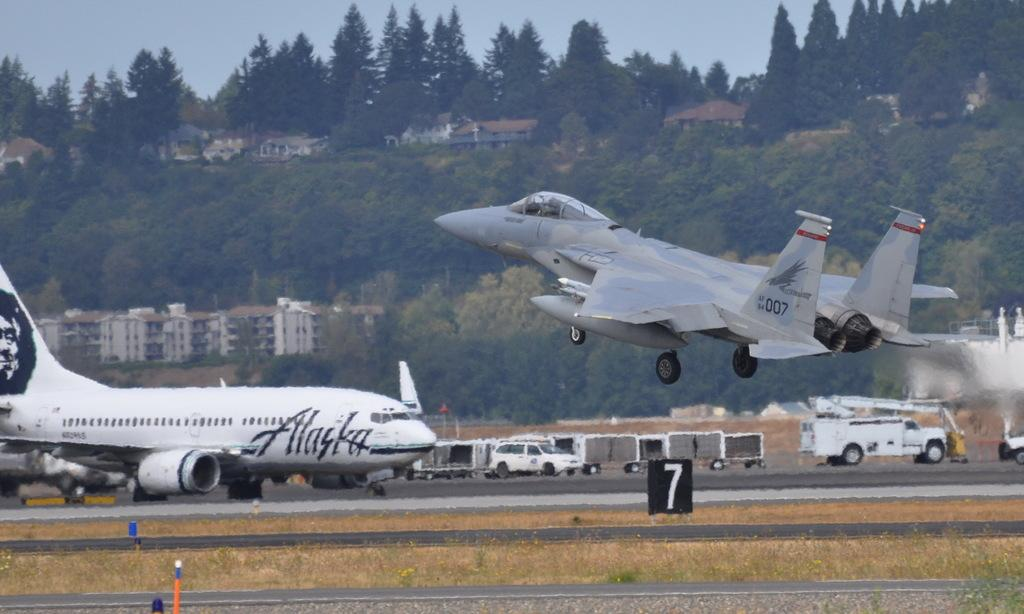<image>
Relay a brief, clear account of the picture shown. A jet labeled 007 takes off with an Alaska plane in the background. 